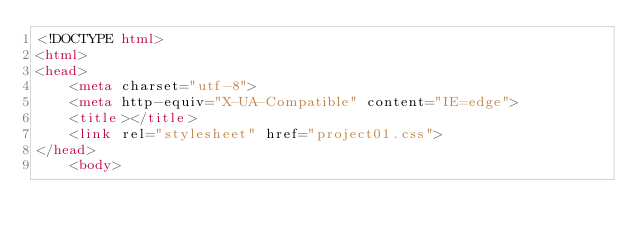Convert code to text. <code><loc_0><loc_0><loc_500><loc_500><_HTML_><!DOCTYPE html>
<html>
<head>
	<meta charset="utf-8">
	<meta http-equiv="X-UA-Compatible" content="IE=edge">
	<title></title>
	<link rel="stylesheet" href="project01.css">
</head>
	<body>
		</code> 